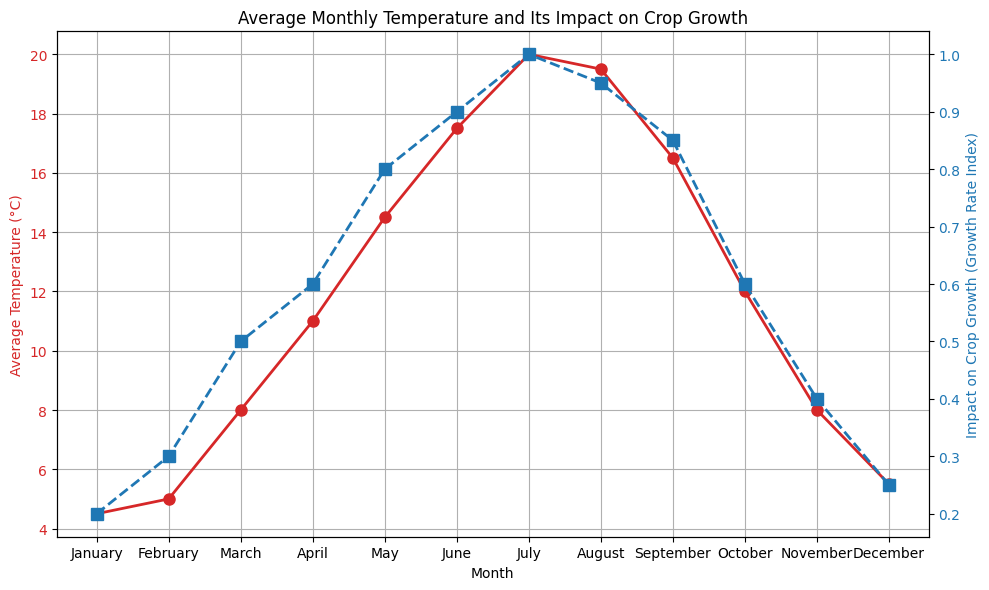Which month has the highest average temperature? By looking at the red line plot, identify the highest point which tells the month with the maximum average temperature.
Answer: July During which month does the impact on crop growth reach its highest index? Observe the blue dashed line and determine the peak point indicating the maximum impact on crop growth.
Answer: July What is the difference in the average temperature between January and July? Subtract the average temperature in January (4.5°C) from the average temperature in July (20°C).
Answer: 15.5°C In which months is the impact on crop growth greater than 0.8? Look for all points on the blue dashed line where the growth rate index is above 0.8 and identify the corresponding months.
Answer: May, June, July, August, September How much does the growth rate index increase from March to April? Subtract the growth rate index in March (0.5) from the index in April (0.6).
Answer: 0.1 What is the average growth rate index for the first half of the year (January to June)? Sum the growth rate indices for January, February, March, April, May, and June and then divide by 6. (0.2 + 0.3 + 0.5 + 0.6 + 0.8 + 0.9) / 6
Answer: 0.55 Which month shows a higher impact on crop growth: February or November? Compare the growth rate indices for February (0.3) and November (0.4).
Answer: November In which month is the average temperature closest to the growing threshold (0.5 growth rate index)? Identify the month where the growth rate index is 0.5 and then look at the corresponding average temperature for that month.
Answer: March During what range of months is the average temperature increasing consistently? Observe the trend of the red line plot and look for the months where the temperature continuously increases.
Answer: January to July Is the impact on crop growth more stable in the first half or the second half of the year? Compare the variability of the growth rate index between January-June and July-December by observing the blue dashed line.
Answer: Second half 